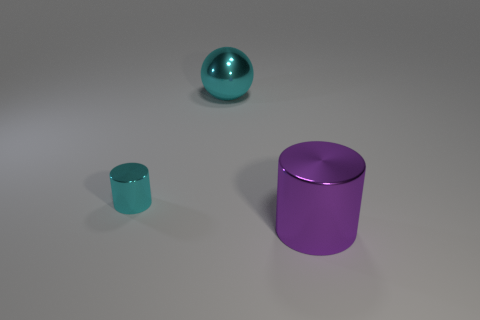Add 2 yellow metallic cylinders. How many objects exist? 5 Subtract all cylinders. How many objects are left? 1 Subtract 0 green cylinders. How many objects are left? 3 Subtract all small blue blocks. Subtract all small cylinders. How many objects are left? 2 Add 3 large cyan spheres. How many large cyan spheres are left? 4 Add 3 balls. How many balls exist? 4 